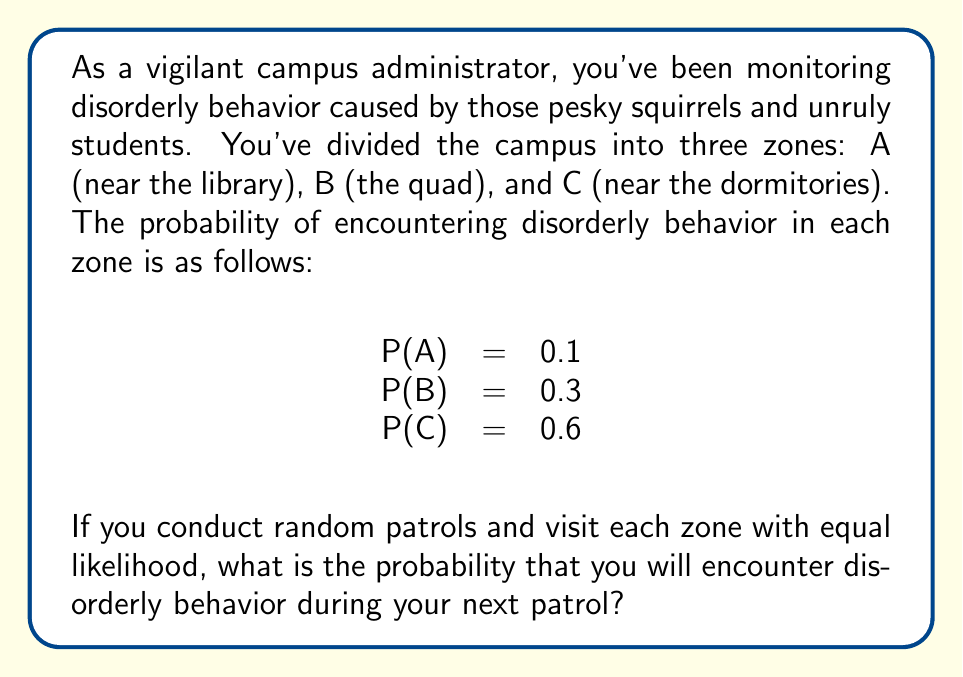What is the answer to this math problem? To solve this problem, we'll use the law of total probability. Let's break it down step-by-step:

1) First, let's define our events:
   D: Encountering disorderly behavior
   A, B, C: Patrolling in zones A, B, and C respectively

2) We're given the following probabilities:
   P(D|A) = 0.1 (probability of disorderly behavior given we're in zone A)
   P(D|B) = 0.3 (probability of disorderly behavior given we're in zone B)
   P(D|C) = 0.6 (probability of disorderly behavior given we're in zone C)

3) Since we visit each zone with equal likelihood, we have:
   P(A) = P(B) = P(C) = 1/3

4) Now, we can apply the law of total probability:
   P(D) = P(D|A) * P(A) + P(D|B) * P(B) + P(D|C) * P(C)

5) Substituting our values:
   P(D) = 0.1 * (1/3) + 0.3 * (1/3) + 0.6 * (1/3)

6) Simplifying:
   P(D) = (0.1 + 0.3 + 0.6) / 3
   P(D) = 1 / 3 = 0.3333...

Therefore, the probability of encountering disorderly behavior during your next patrol is approximately 0.3333 or 33.33%.
Answer: The probability of encountering disorderly behavior during the next patrol is $\frac{1}{3}$ or approximately $0.3333$ (33.33%). 